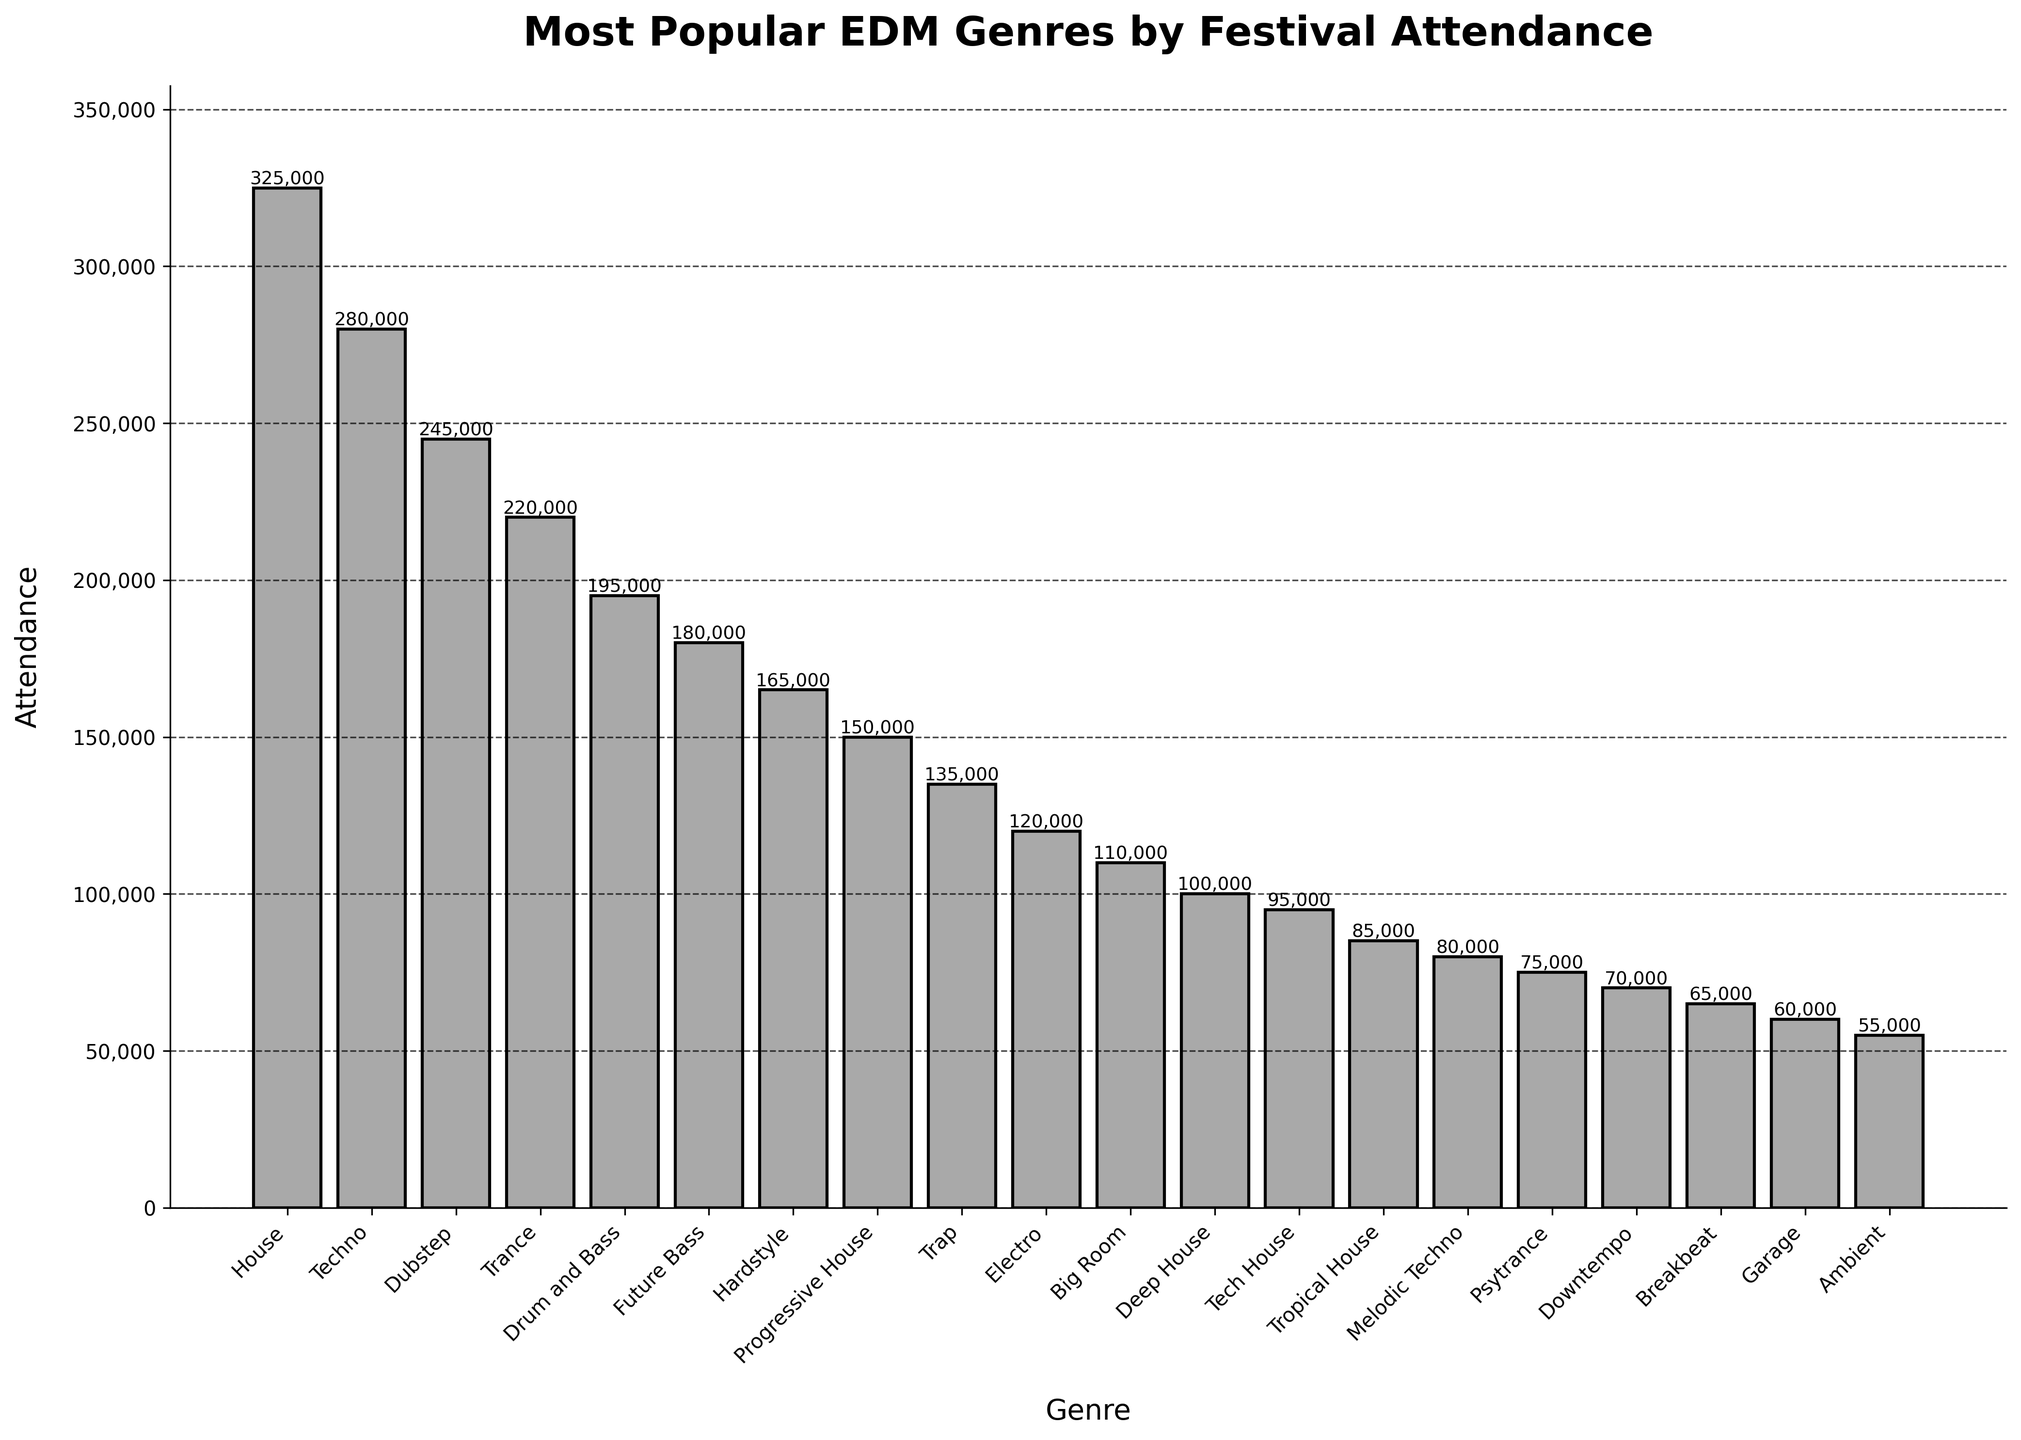Which genre has the highest festival attendance? To find the genre with the highest festival attendance, look at the tallest bar in the chart, which represents House with 325,000 attendees.
Answer: House What's the difference in attendance between Techno and Dubstep? Techno has an attendance of 280,000 and Dubstep has 245,000. Subtract the attendance of Dubstep from that of Techno (280,000 - 245,000) to find the difference.
Answer: 35,000 Which genre has a lower attendance, Progressive House or Trap? Look at the heights of the bars for Progressive House and Trap. Progressive House has an attendance of 150,000, while Trap has 135,000. Since 135,000 is less than 150,000, Trap has lower attendance.
Answer: Trap What is the total attendance for Tech House, Tropical House, and Melodic Techno combined? Add the attendance figures for these genres: Tech House (95,000), Tropical House (85,000), and Melodic Techno (80,000). The total is 95,000 + 85,000 + 80,000 = 260,000.
Answer: 260,000 Which genres have an attendance higher than 200,000? Look at the bars that have a height representing more than 200,000 attendees. These genres are House (325,000), Techno (280,000), Dubstep (245,000), and Trance (220,000).
Answer: House, Techno, Dubstep, Trance What is the median festival attendance across all genres? To find the median, list all attendance numbers in ascending order: 55,000, 60,000, 65,000, 70,000, 75,000, 80,000, 85,000, 95,000, 100,000, 110,000, 120,000, 135,000, 150,000, 165,000, 180,000, 195,000, 220,000, 245,000, 280,000, 325,000. The median is the middle value in this ordered list, which is the 10th and 11th values averaged: (120,000 + 135,000) / 2 = 127,500.
Answer: 127,500 How does the attendance for Drum and Bass compare to that for Future Bass? Drum and Bass has an attendance of 195,000, while Future Bass has 180,000. Since 195,000 is greater than 180,000, Drum and Bass has a higher attendance.
Answer: Drum and Bass How much higher is the attendance of Hardstyle compared to Big Room? Hardstyle has 165,000 attendees, and Big Room has 110,000. Subtract the attendance of Big Room from that of Hardstyle (165,000 - 110,000) to find the difference.
Answer: 55,000 